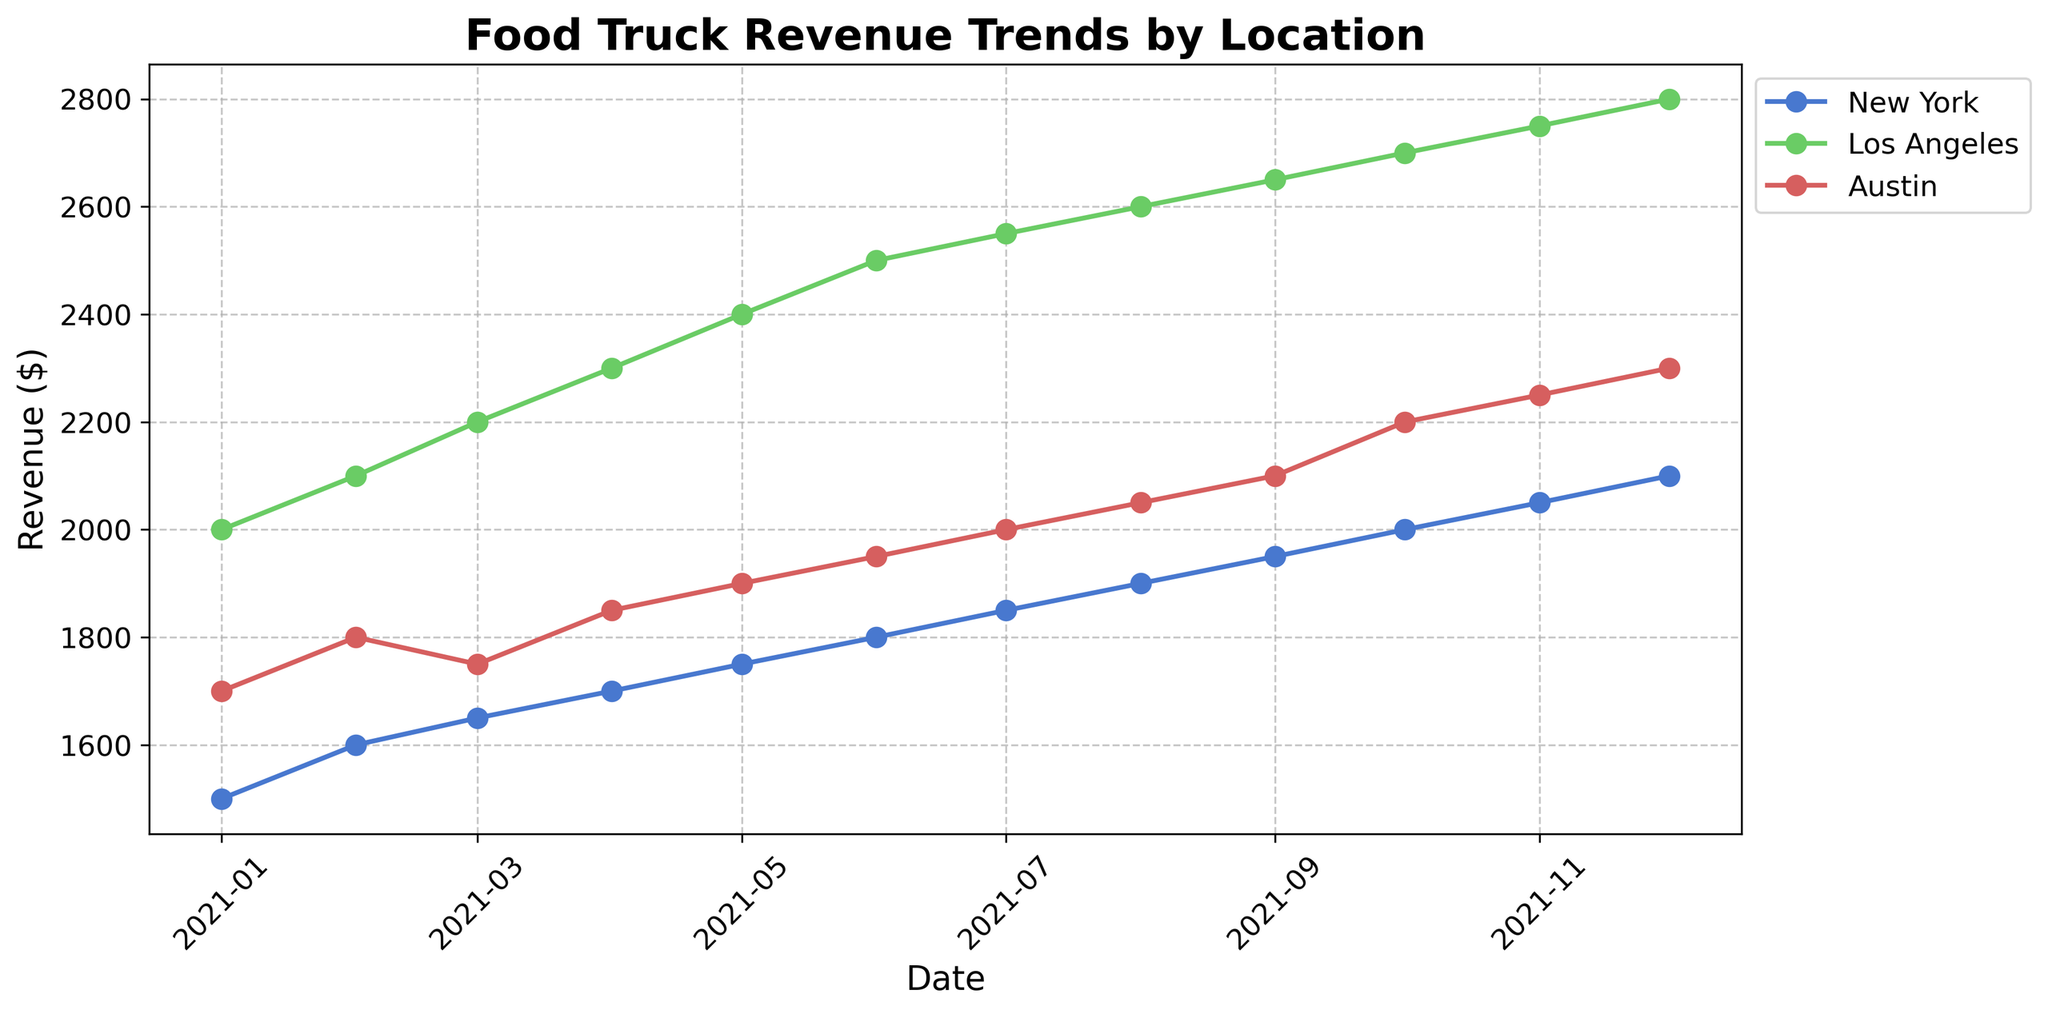What is the title of the plot? The title of the plot is usually displayed at the top center of the figure. In this case, it is: "Food Truck Revenue Trends by Location"
Answer: Food Truck Revenue Trends by Location What locations are displayed in the plot? To find the locations, you need to look at the legend on the plot, which lists the unique locations being tracked.
Answer: New York, Los Angeles, Austin Which food truck had the highest revenue in December 2021? In the plot, find the point corresponding to December 2021 and compare the revenue values across New York, Los Angeles, and Austin. The food truck with the highest value is the one in Los Angeles.
Answer: Taco Wizards What is the revenue trend for the food truck in New York throughout 2021? To determine the trend, observe the trajectory of the revenue line for New York. The revenue generally increases throughout the year, starting at $1500 in January and ending at $2100 in December.
Answer: Increasing By how much did the revenue for "Burger Bros" in Austin increase from January 2021 to December 2021? Identify the revenue points for "Burger Bros" in January ($1700) and December ($2300). The difference between the two points gives the increase. Calculation: $2300 - $1700 = $600
Answer: $600 How does the revenue trend for "Taco Wizards" in Los Angeles compare to that of "Big Apple Bites" in New York? Compare the slopes of the lines for "Taco Wizards" and "Big Apple Bites". Both lines show an increasing trend, but "Taco Wizards" rises more sharply than "Big Apple Bites", indicating a more significant growth.
Answer: More sharply increasing What is the total revenue for "Big Apple Bites" over the whole year of 2021? Sum the monthly revenues for "Big Apple Bites" from January to December: $1500 + $1600 + $1650 + $1700 + $1750 + $1800 + $1850 + $1900 + $1950 + $2000 + $2050 + $2100
Answer: $21850 In which month did "Burger Bros" in Austin see the highest revenue, and what was the value? Look at the peak of the revenue line for "Burger Bros". The highest point is in December 2021, where the revenue is $2300.
Answer: December, $2300 What was the trend in revenue during the first half of 2021 for "Big Apple Bites" in New York, and how does it compare to the second half of the year? Examine the revenue line for "Big Apple Bites" from January to June and then from July to December. The first half shows a steady increase from $1500 to $1800, whereas the second half also shows a steady increase from $1850 to $2100, reflecting consistent growth throughout the year.
Answer: Steady increase, consistent growth 